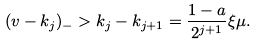<formula> <loc_0><loc_0><loc_500><loc_500>( v - k _ { j } ) _ { - } > k _ { j } - k _ { j + 1 } = \frac { 1 - a } { 2 ^ { j + 1 } } \xi \mu .</formula> 